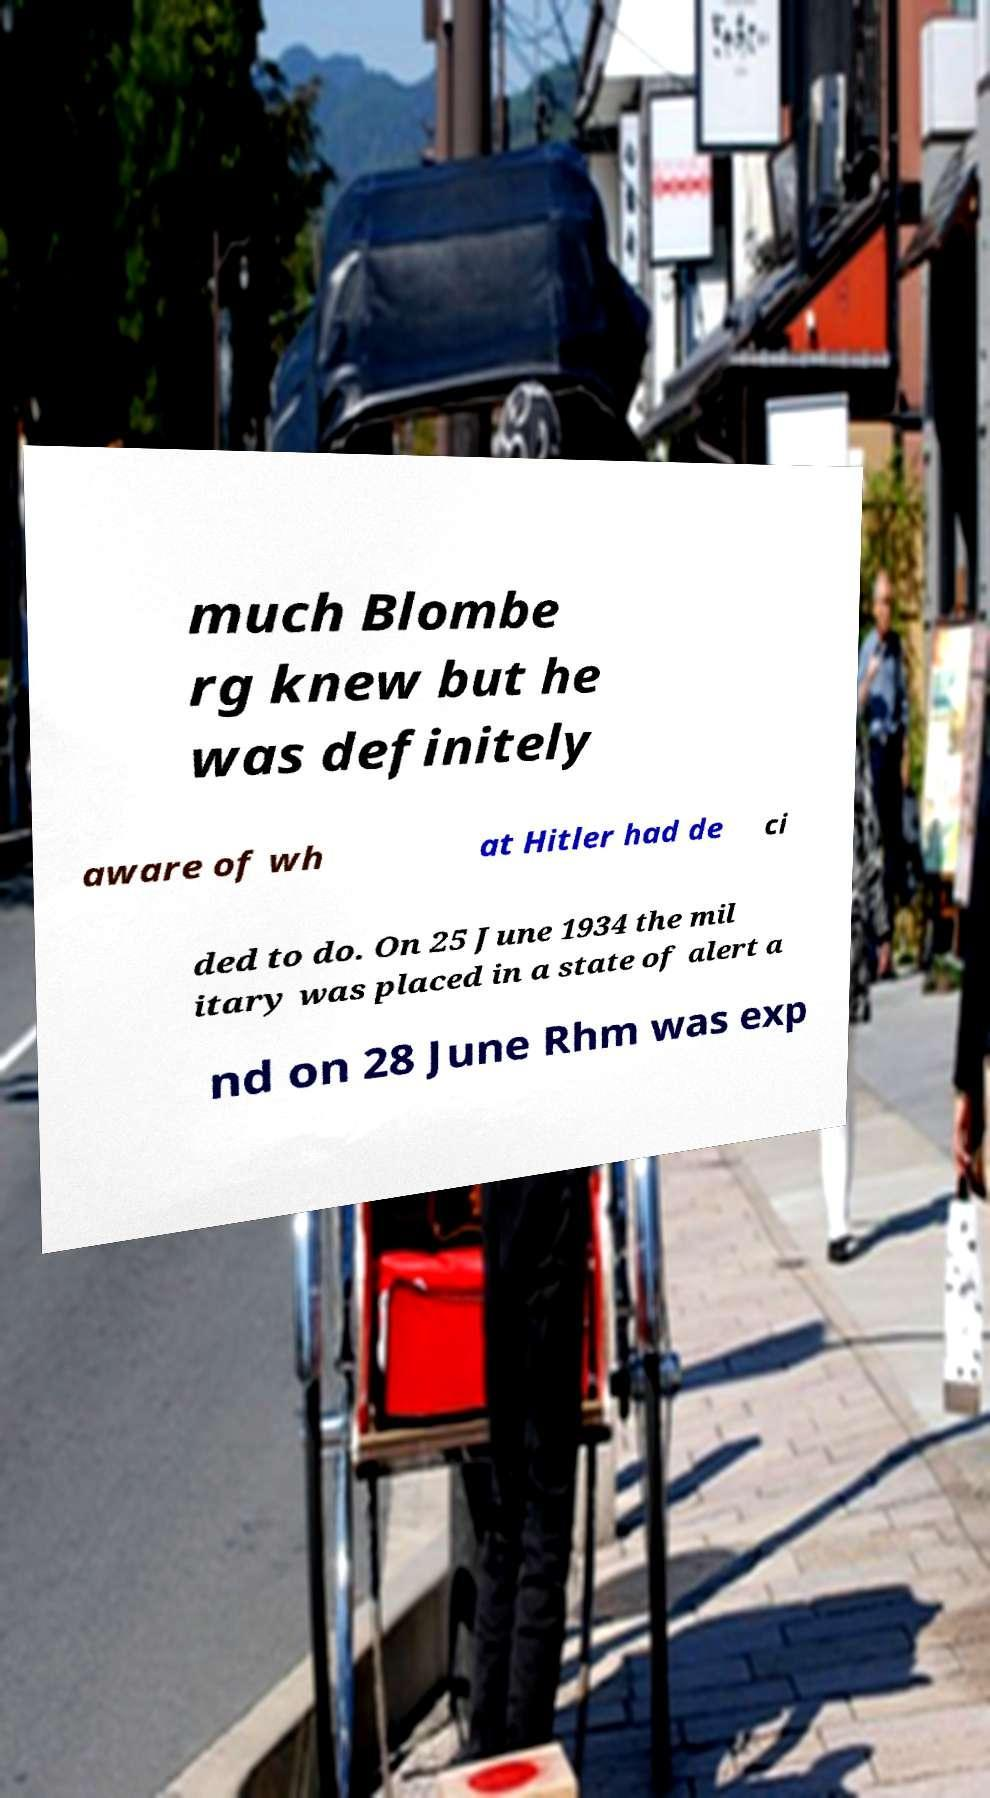Can you accurately transcribe the text from the provided image for me? much Blombe rg knew but he was definitely aware of wh at Hitler had de ci ded to do. On 25 June 1934 the mil itary was placed in a state of alert a nd on 28 June Rhm was exp 